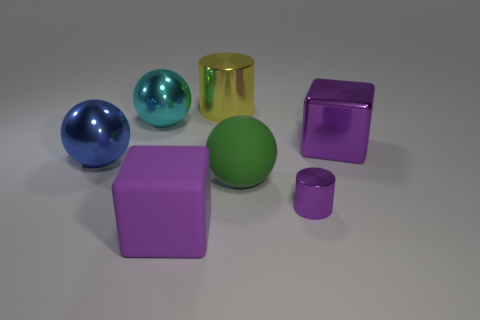Is there anything else that has the same size as the purple metal cylinder?
Your answer should be very brief. No. There is a purple metal object in front of the big purple cube behind the large blue metallic ball; how many tiny purple cylinders are right of it?
Your answer should be compact. 0. Do the matte object that is left of the big cylinder and the small metal cylinder have the same color?
Your response must be concise. Yes. What number of other objects are the same shape as the small purple shiny thing?
Give a very brief answer. 1. How many other objects are there of the same material as the big cyan sphere?
Ensure brevity in your answer.  4. What is the material of the big purple thing in front of the large purple cube to the right of the rubber thing that is on the right side of the yellow thing?
Provide a succinct answer. Rubber. Are the small purple object and the green ball made of the same material?
Make the answer very short. No. What number of cylinders are either small gray rubber objects or large yellow things?
Make the answer very short. 1. What is the color of the metal object that is in front of the large green matte ball?
Offer a very short reply. Purple. How many metal things are cyan balls or purple blocks?
Your answer should be very brief. 2. 